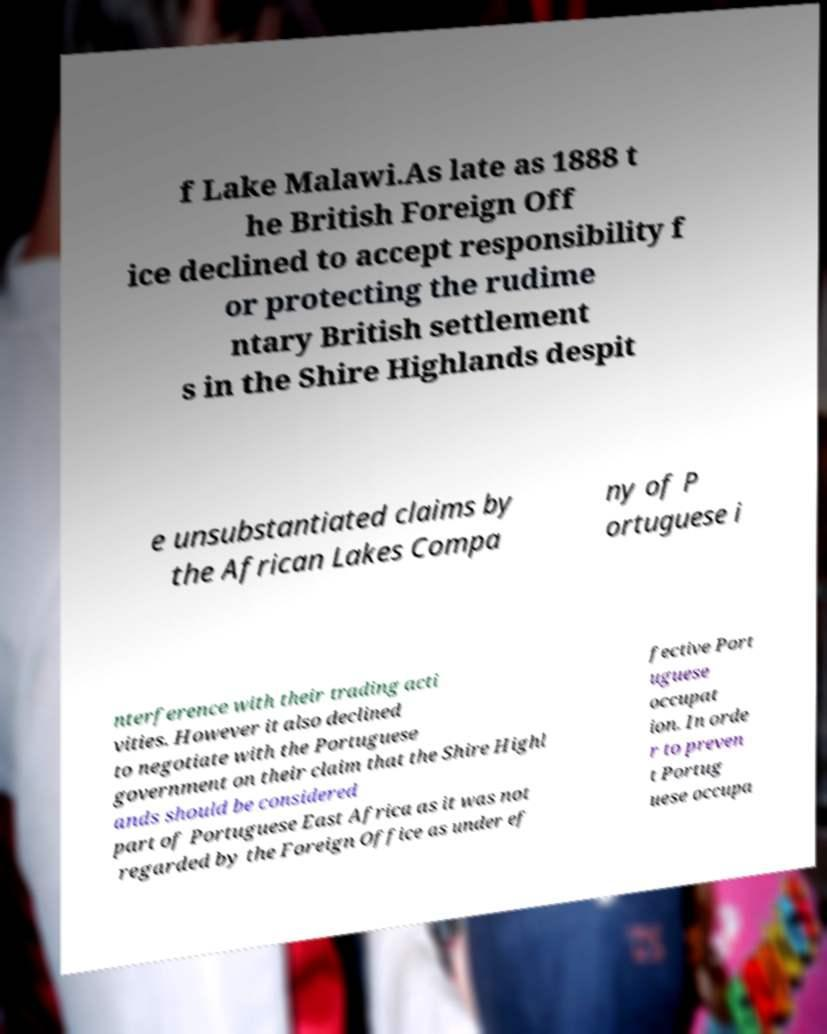What messages or text are displayed in this image? I need them in a readable, typed format. f Lake Malawi.As late as 1888 t he British Foreign Off ice declined to accept responsibility f or protecting the rudime ntary British settlement s in the Shire Highlands despit e unsubstantiated claims by the African Lakes Compa ny of P ortuguese i nterference with their trading acti vities. However it also declined to negotiate with the Portuguese government on their claim that the Shire Highl ands should be considered part of Portuguese East Africa as it was not regarded by the Foreign Office as under ef fective Port uguese occupat ion. In orde r to preven t Portug uese occupa 